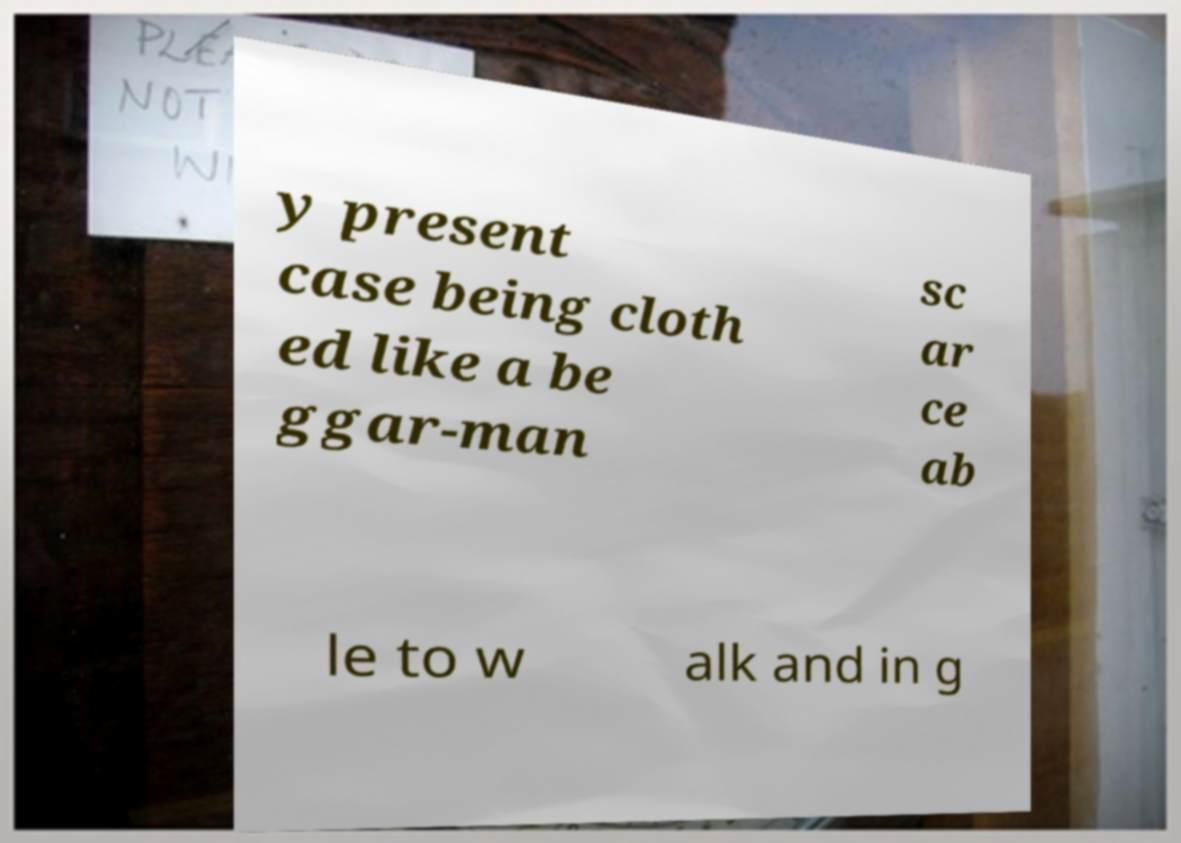Could you assist in decoding the text presented in this image and type it out clearly? y present case being cloth ed like a be ggar-man sc ar ce ab le to w alk and in g 